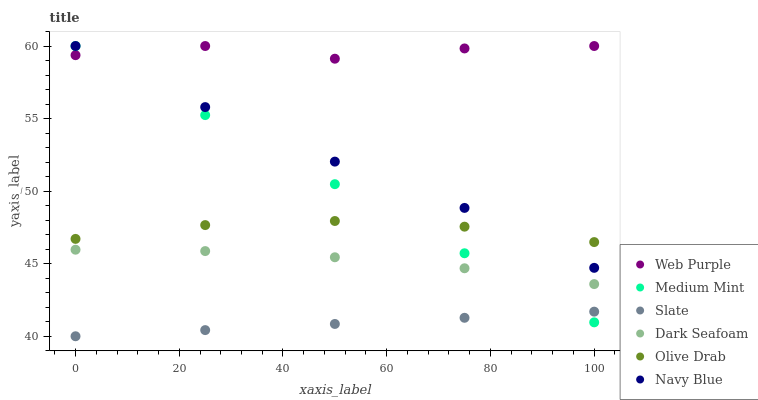Does Slate have the minimum area under the curve?
Answer yes or no. Yes. Does Web Purple have the maximum area under the curve?
Answer yes or no. Yes. Does Navy Blue have the minimum area under the curve?
Answer yes or no. No. Does Navy Blue have the maximum area under the curve?
Answer yes or no. No. Is Slate the smoothest?
Answer yes or no. Yes. Is Web Purple the roughest?
Answer yes or no. Yes. Is Navy Blue the smoothest?
Answer yes or no. No. Is Navy Blue the roughest?
Answer yes or no. No. Does Slate have the lowest value?
Answer yes or no. Yes. Does Navy Blue have the lowest value?
Answer yes or no. No. Does Web Purple have the highest value?
Answer yes or no. Yes. Does Slate have the highest value?
Answer yes or no. No. Is Dark Seafoam less than Olive Drab?
Answer yes or no. Yes. Is Olive Drab greater than Slate?
Answer yes or no. Yes. Does Web Purple intersect Medium Mint?
Answer yes or no. Yes. Is Web Purple less than Medium Mint?
Answer yes or no. No. Is Web Purple greater than Medium Mint?
Answer yes or no. No. Does Dark Seafoam intersect Olive Drab?
Answer yes or no. No. 